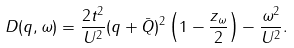<formula> <loc_0><loc_0><loc_500><loc_500>D ( q , \omega ) = \frac { 2 t ^ { 2 } } { U ^ { 2 } } ( q + { \bar { Q } } ) ^ { 2 } \left ( 1 - \frac { z _ { \omega } } { 2 } \right ) - \frac { \omega ^ { 2 } } { U ^ { 2 } } .</formula> 